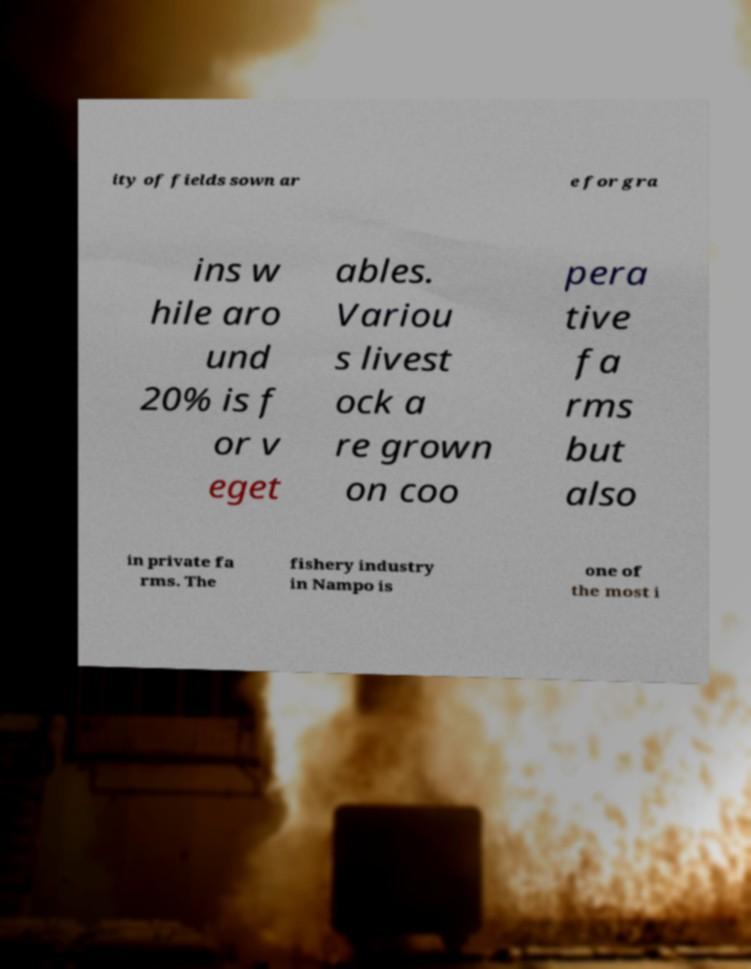For documentation purposes, I need the text within this image transcribed. Could you provide that? ity of fields sown ar e for gra ins w hile aro und 20% is f or v eget ables. Variou s livest ock a re grown on coo pera tive fa rms but also in private fa rms. The fishery industry in Nampo is one of the most i 